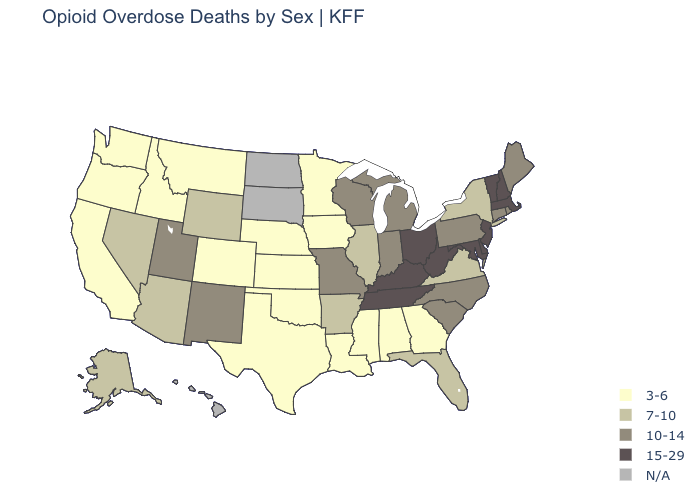What is the highest value in the USA?
Give a very brief answer. 15-29. What is the value of New Hampshire?
Keep it brief. 15-29. Name the states that have a value in the range N/A?
Keep it brief. Hawaii, North Dakota, South Dakota. What is the lowest value in states that border Maryland?
Short answer required. 7-10. Does the map have missing data?
Be succinct. Yes. Is the legend a continuous bar?
Concise answer only. No. What is the lowest value in the Northeast?
Concise answer only. 7-10. What is the highest value in the USA?
Be succinct. 15-29. Does the map have missing data?
Be succinct. Yes. What is the lowest value in the Northeast?
Keep it brief. 7-10. What is the value of Washington?
Give a very brief answer. 3-6. Name the states that have a value in the range 10-14?
Answer briefly. Connecticut, Indiana, Maine, Michigan, Missouri, New Mexico, North Carolina, Pennsylvania, Rhode Island, South Carolina, Utah, Wisconsin. 